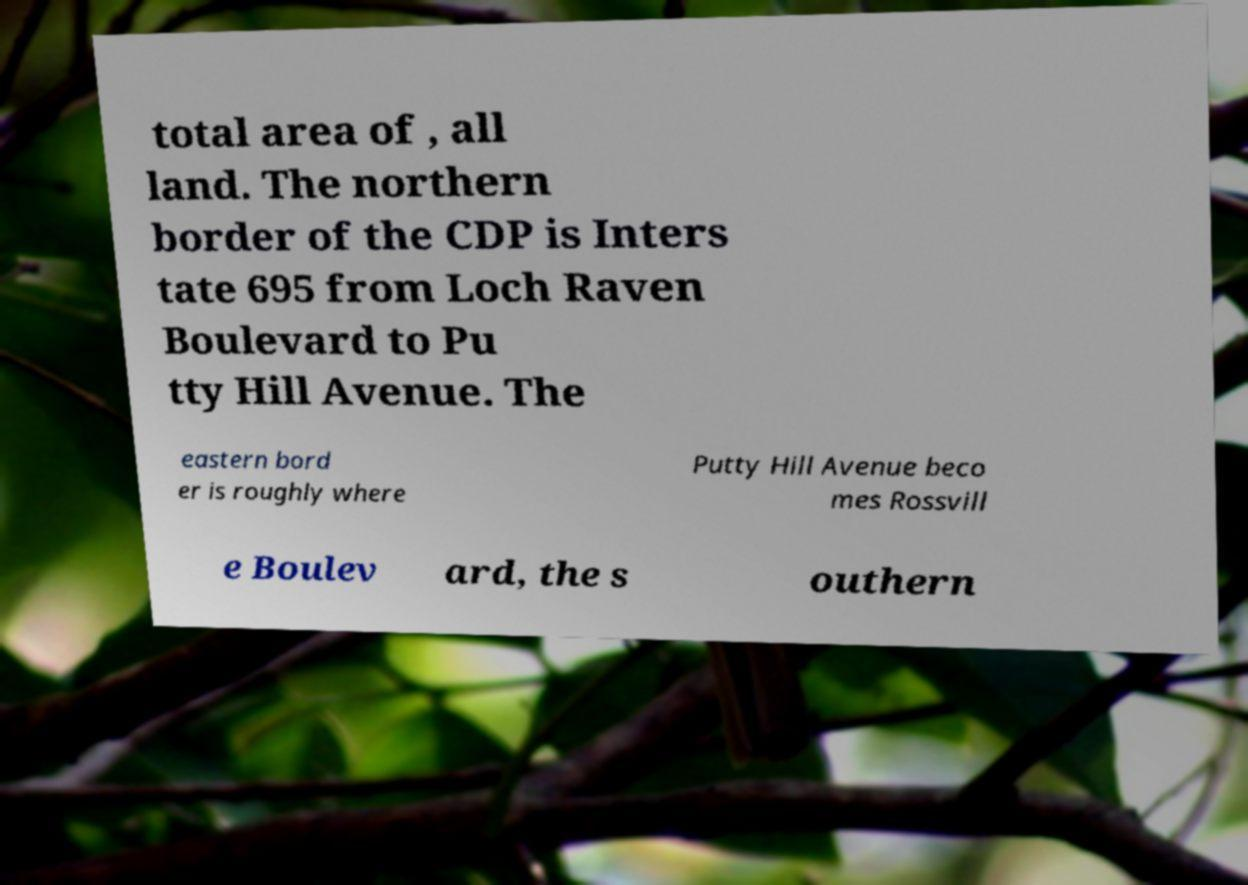For documentation purposes, I need the text within this image transcribed. Could you provide that? total area of , all land. The northern border of the CDP is Inters tate 695 from Loch Raven Boulevard to Pu tty Hill Avenue. The eastern bord er is roughly where Putty Hill Avenue beco mes Rossvill e Boulev ard, the s outhern 